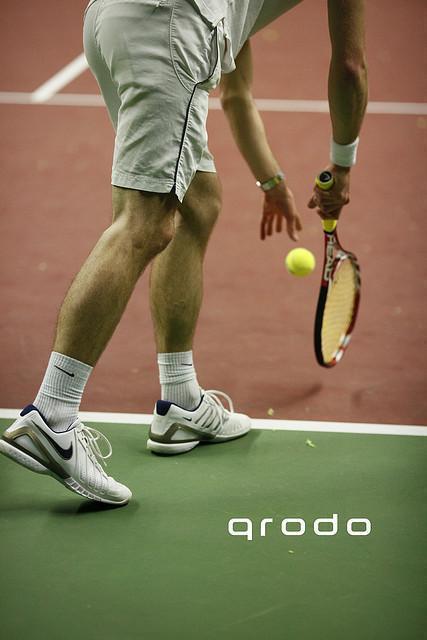How many cats are sitting on the blanket?
Give a very brief answer. 0. 